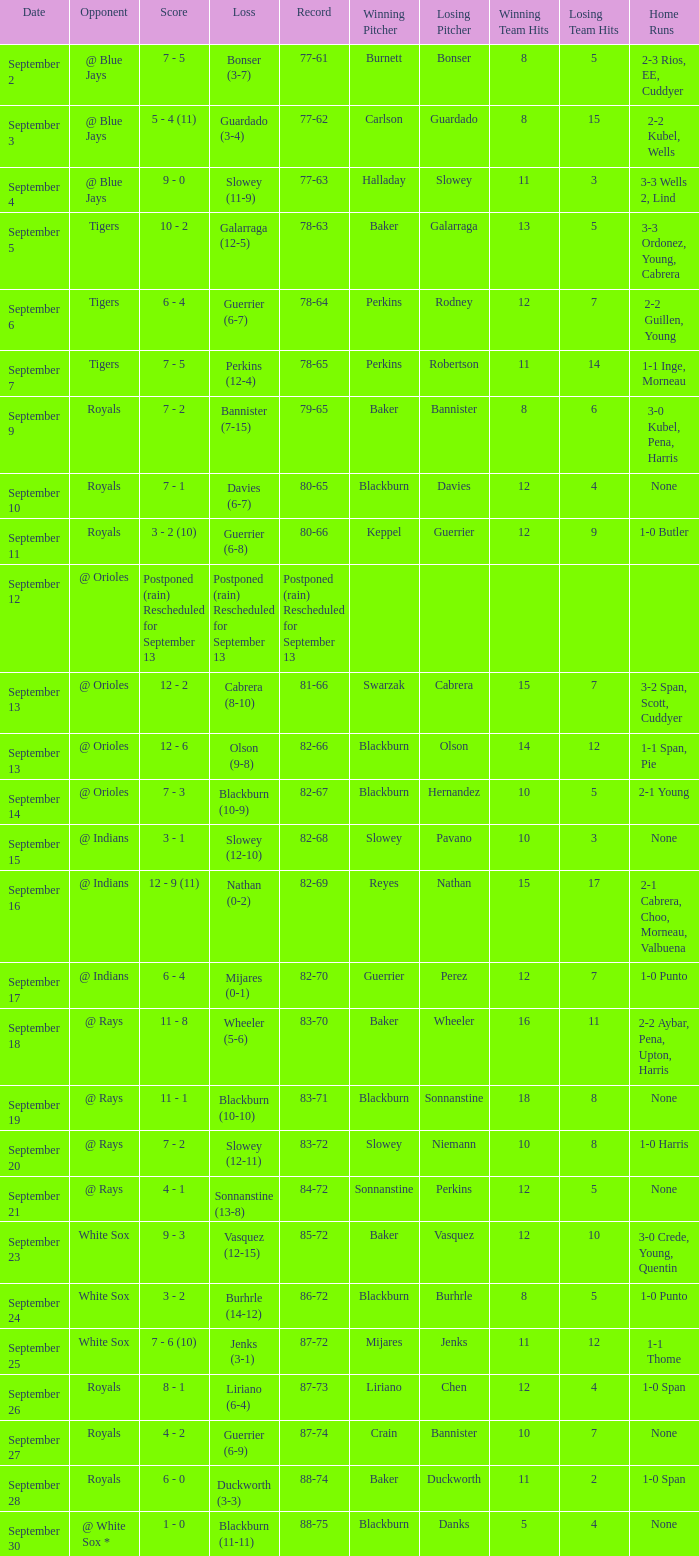What opponent has the record of 78-63? Tigers. 